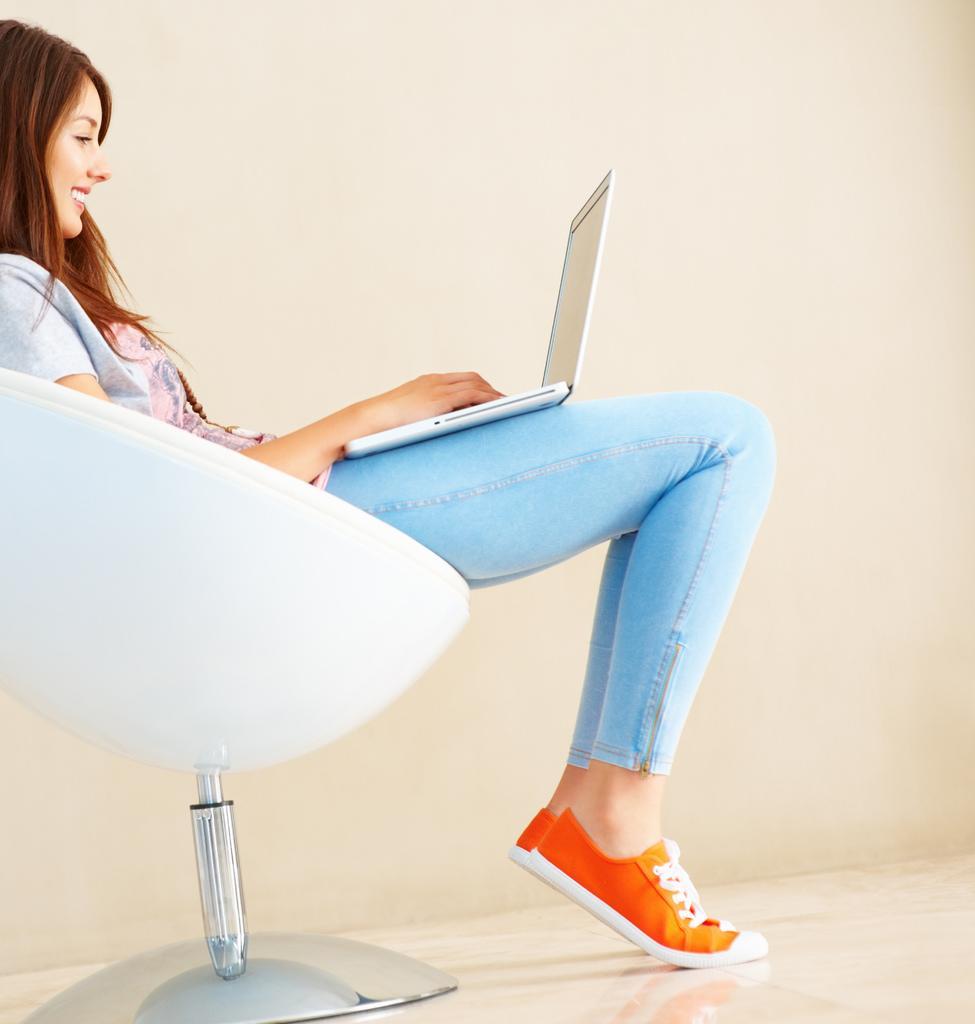Can you describe this image briefly? This picture shows a woman seated on the chair and using her laptop with a smile on her face 